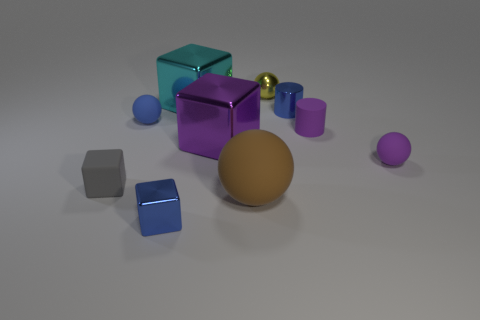Is the number of small spheres less than the number of large metal cylinders?
Make the answer very short. No. There is a tiny object that is in front of the tiny gray rubber cube left of the big brown thing; what number of rubber balls are on the right side of it?
Provide a short and direct response. 2. What is the size of the cylinder that is in front of the tiny blue cylinder?
Provide a succinct answer. Small. There is a tiny blue metal thing that is in front of the tiny gray matte thing; is its shape the same as the big matte object?
Provide a succinct answer. No. There is a blue thing that is the same shape as the big brown rubber object; what material is it?
Provide a short and direct response. Rubber. Are there any large blocks?
Your response must be concise. Yes. What material is the tiny block in front of the small cube that is on the left side of the shiny thing in front of the big rubber object?
Your answer should be compact. Metal. Is the shape of the large cyan shiny object the same as the blue thing that is to the right of the big brown ball?
Provide a short and direct response. No. What number of big cyan things have the same shape as the gray object?
Provide a succinct answer. 1. What is the shape of the large brown matte object?
Provide a succinct answer. Sphere. 